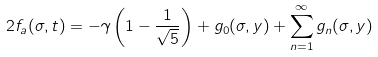Convert formula to latex. <formula><loc_0><loc_0><loc_500><loc_500>2 f _ { a } ( \sigma , t ) & = - \gamma \left ( 1 - \frac { 1 } { \sqrt { 5 } } \right ) + g _ { 0 } ( \sigma , y ) + \sum _ { n = 1 } ^ { \infty } g _ { n } ( \sigma , y )</formula> 